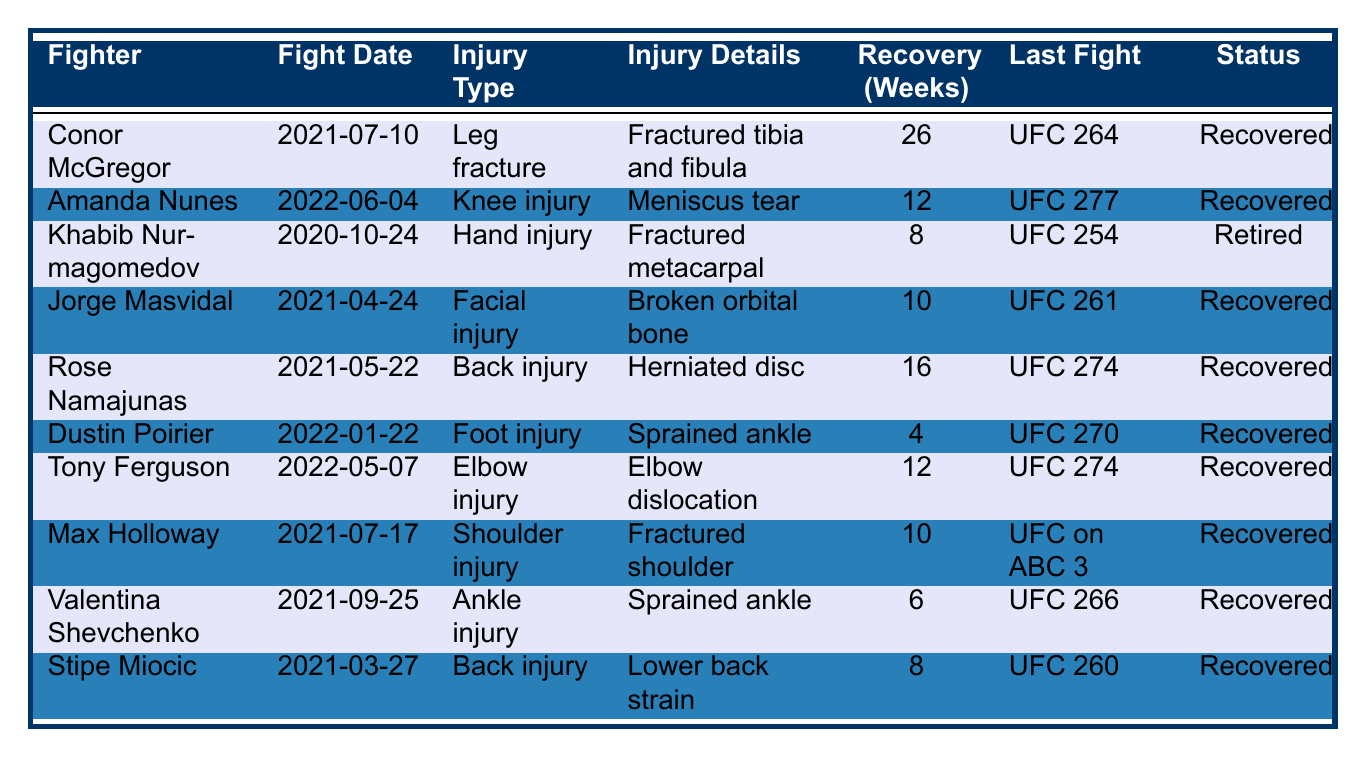What is the injury type of Conor McGregor? According to the table, Conor McGregor has a "Leg fracture" as his injury type.
Answer: Leg fracture How many weeks did it take for Amanda Nunes to recover? The table indicates that Amanda Nunes's recovery time was 12 weeks.
Answer: 12 weeks Which fighter sustained an elbow injury? The table shows that Tony Ferguson sustained an "Elbow injury."
Answer: Tony Ferguson What was the last fight of Khabib Nurmagomedov? Khabib Nurmagomedov's last fight, according to the table, was at "UFC 254."
Answer: UFC 254 Which fighter has the longest recovery time? By comparing the recovery times listed, Conor McGregor has the longest recovery time, which is 26 weeks.
Answer: 26 weeks How many fighters recovered from their injuries? Reviewing the table, all fighters except Khabib Nurmagomedov are listed as "Recovered," which counts to 9 fighters.
Answer: 9 fighters Did Jorge Masvidal have an injury requiring more than 10 weeks of recovery? According to the table, Jorge Masvidal's recovery time was 10 weeks, which does not exceed 10 weeks; hence, the answer is no.
Answer: No Calculate the average recovery time for fighters in the table. Summing the recovery times: 26 + 12 + 8 + 10 + 16 + 4 + 12 + 10 + 6 + 8 = 88 weeks. There are 10 fighters, so the average is 88/10 = 8.8 weeks.
Answer: 8.8 weeks Which fighter had a sprained ankle and what was their recovery time? According to the table, Dustin Poirier had a "Foot injury" with a sprained ankle, and the recovery time was 4 weeks.
Answer: Dustin Poirier, 4 weeks Is Rose Namajunas still an active fighter based on the table's status? The status for Rose Namajunas is "Recovered," indicating she is still eligible to fight and therefore considered active.
Answer: Yes 